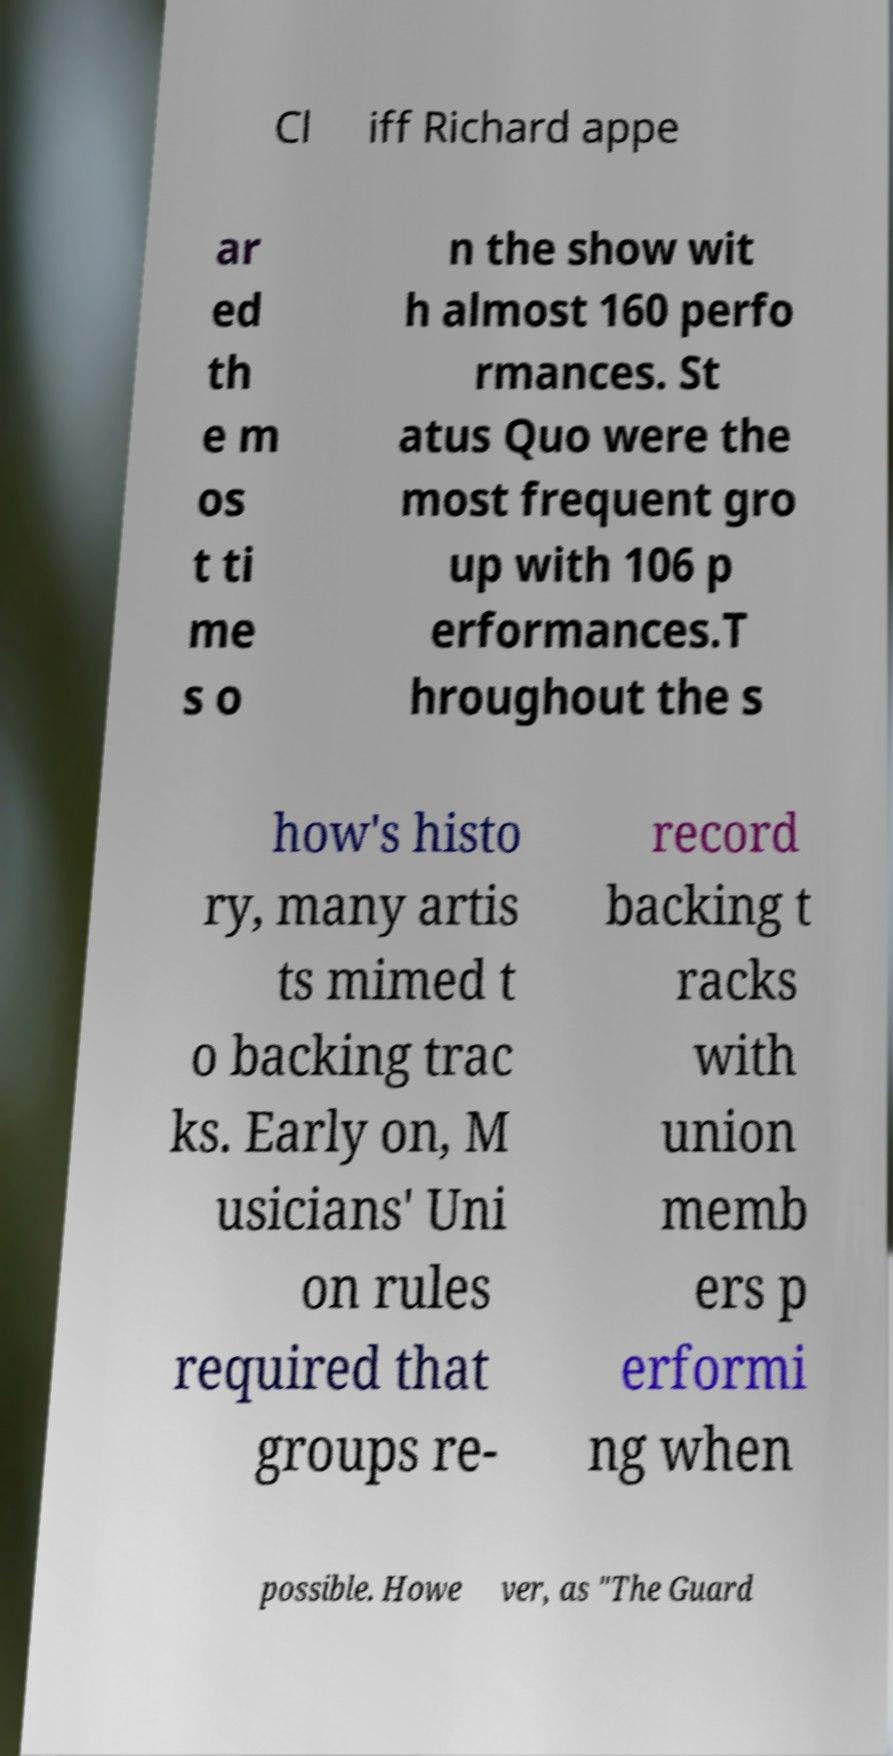I need the written content from this picture converted into text. Can you do that? Cl iff Richard appe ar ed th e m os t ti me s o n the show wit h almost 160 perfo rmances. St atus Quo were the most frequent gro up with 106 p erformances.T hroughout the s how's histo ry, many artis ts mimed t o backing trac ks. Early on, M usicians' Uni on rules required that groups re- record backing t racks with union memb ers p erformi ng when possible. Howe ver, as "The Guard 